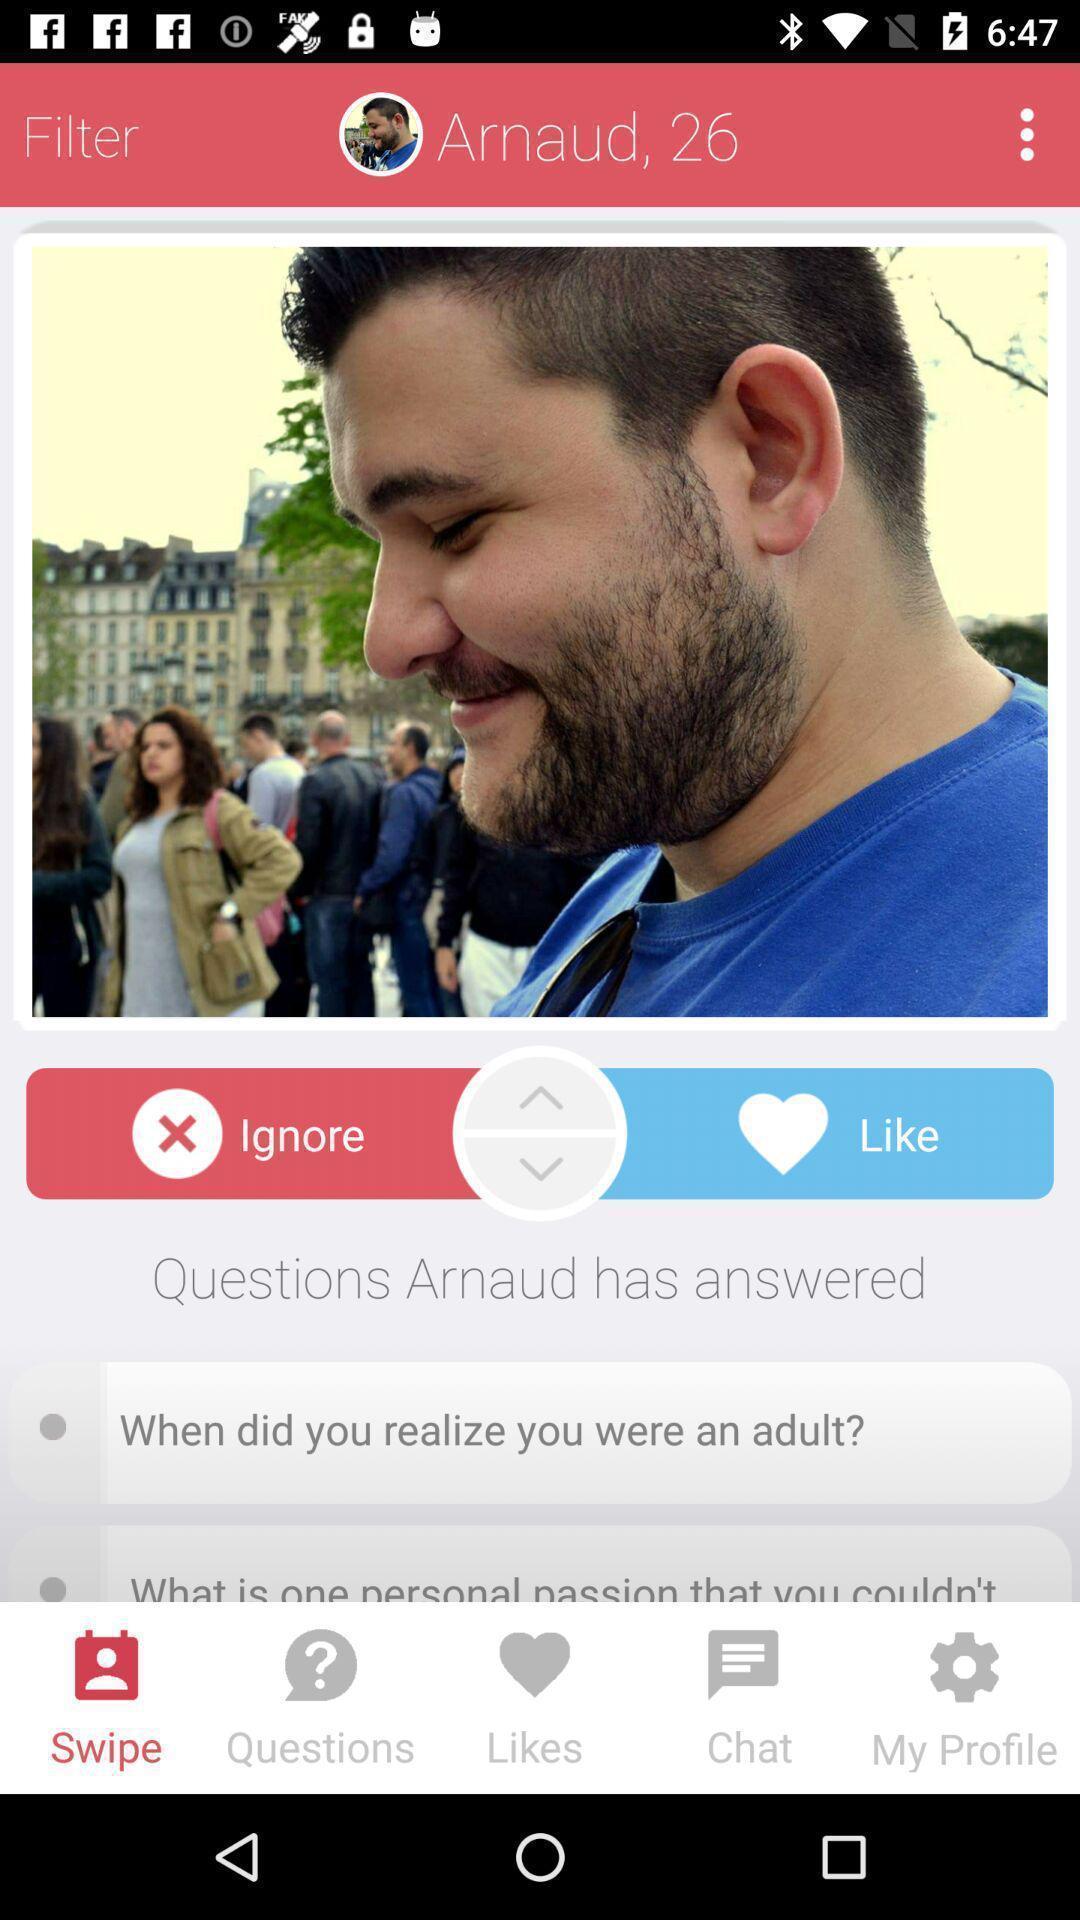Summarize the main components in this picture. Social app showing profiles for dating and chatting. 